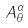<formula> <loc_0><loc_0><loc_500><loc_500>A _ { \theta } ^ { \alpha }</formula> 